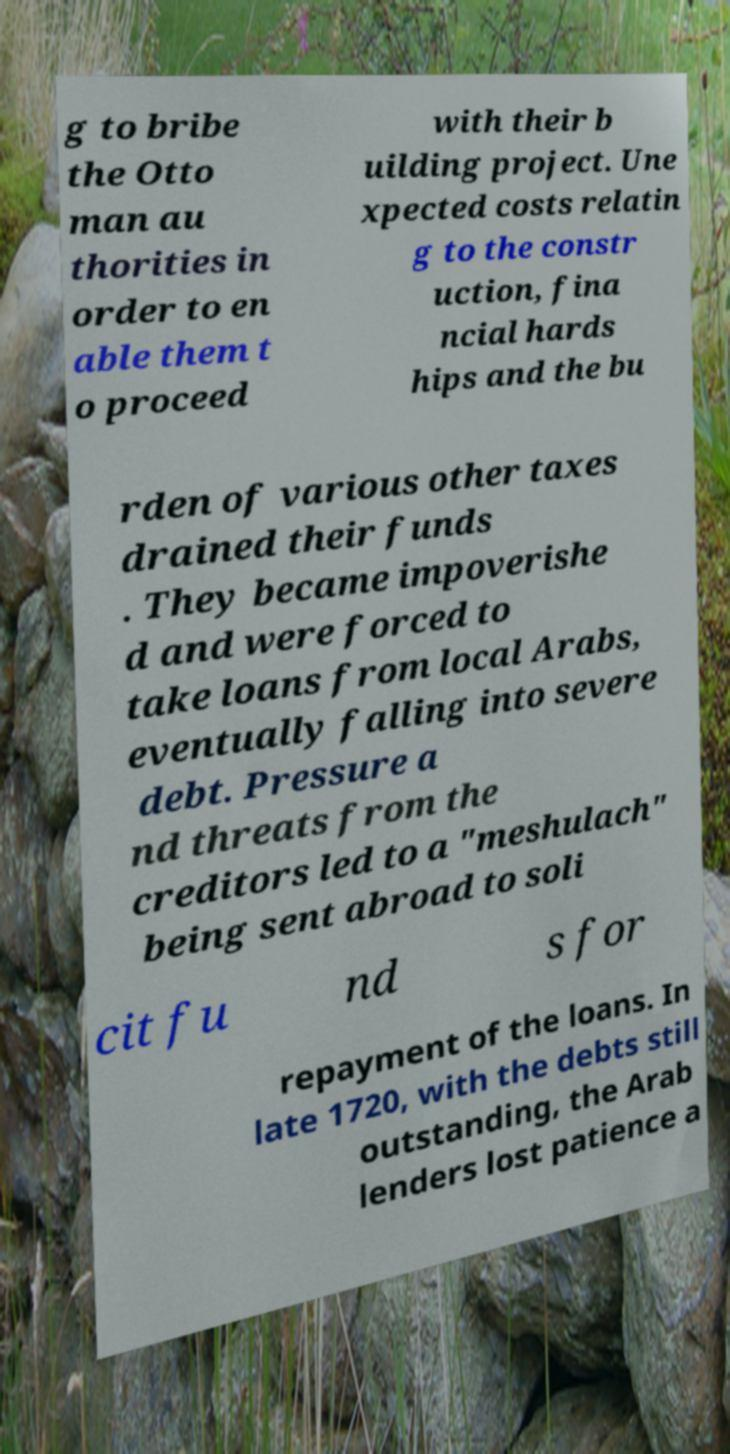Could you assist in decoding the text presented in this image and type it out clearly? g to bribe the Otto man au thorities in order to en able them t o proceed with their b uilding project. Une xpected costs relatin g to the constr uction, fina ncial hards hips and the bu rden of various other taxes drained their funds . They became impoverishe d and were forced to take loans from local Arabs, eventually falling into severe debt. Pressure a nd threats from the creditors led to a "meshulach" being sent abroad to soli cit fu nd s for repayment of the loans. In late 1720, with the debts still outstanding, the Arab lenders lost patience a 